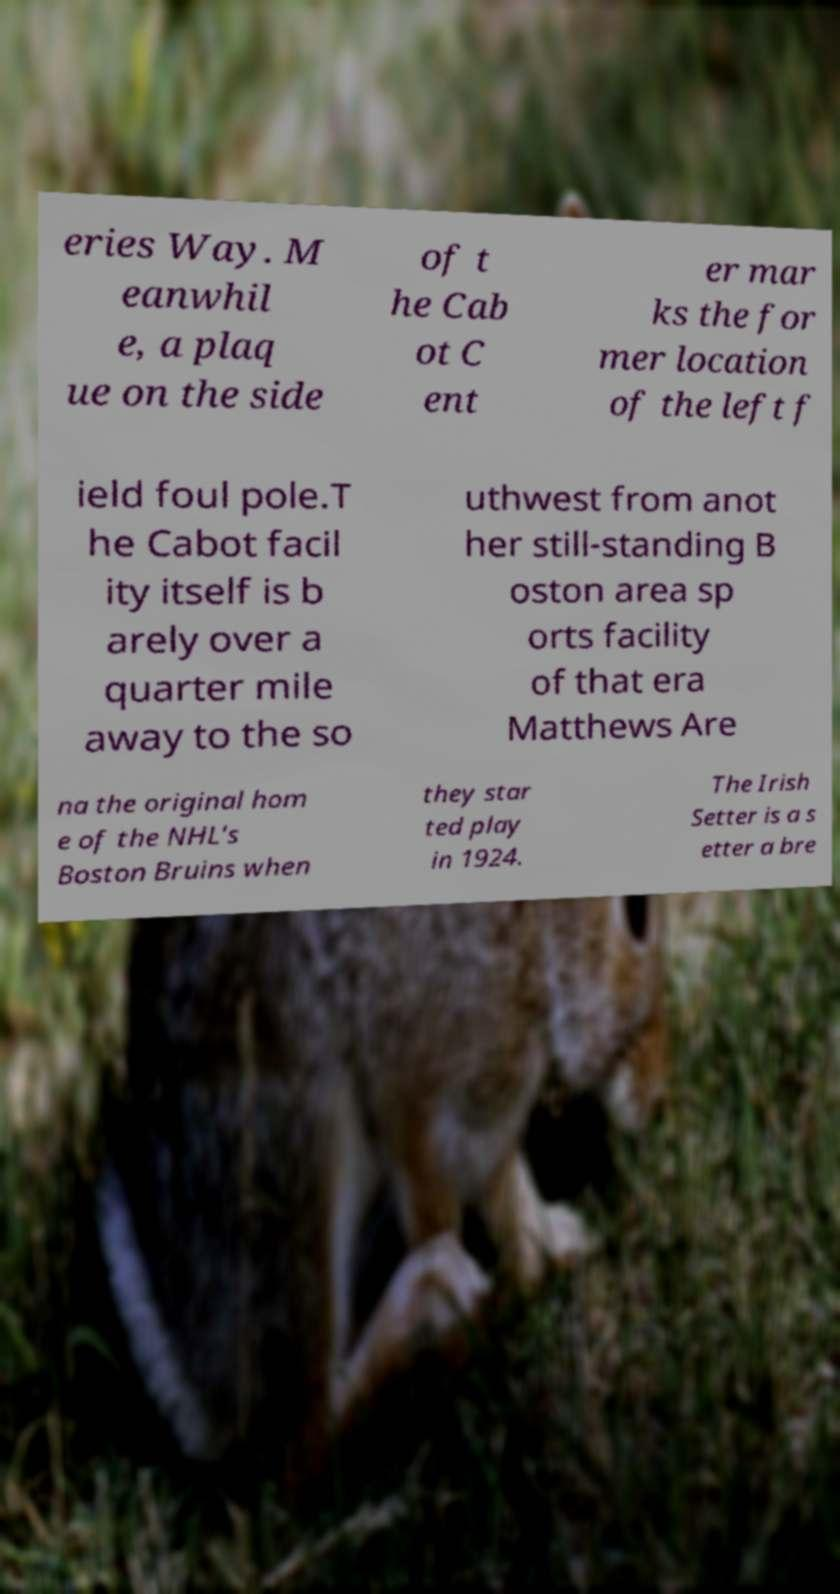I need the written content from this picture converted into text. Can you do that? eries Way. M eanwhil e, a plaq ue on the side of t he Cab ot C ent er mar ks the for mer location of the left f ield foul pole.T he Cabot facil ity itself is b arely over a quarter mile away to the so uthwest from anot her still-standing B oston area sp orts facility of that era Matthews Are na the original hom e of the NHL's Boston Bruins when they star ted play in 1924. The Irish Setter is a s etter a bre 